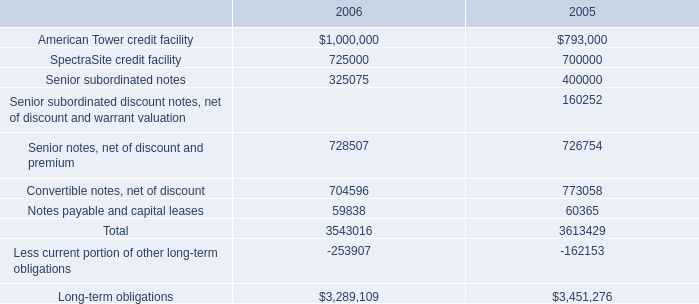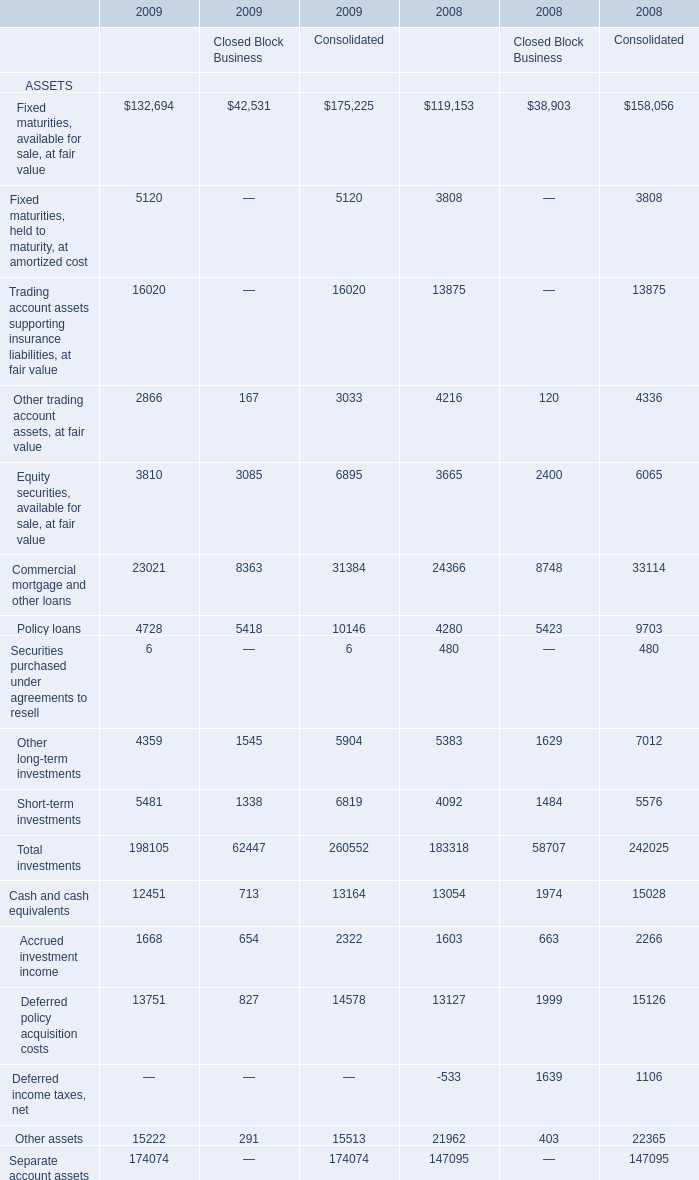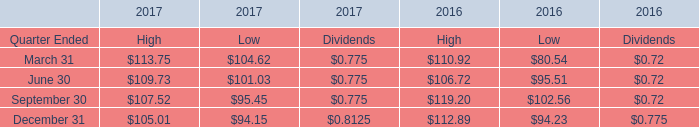In the year with lowest amount of Other long-term investments for Consolidated , what's the increasing rate of Policy loans for Consolidated? 
Computations: ((10146 - 9703) / 9703)
Answer: 0.04566. 